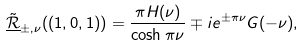Convert formula to latex. <formula><loc_0><loc_0><loc_500><loc_500>\tilde { \underline { \mathcal { R } } } _ { \pm , \nu } ( ( 1 , 0 , 1 ) ) = \frac { \pi H ( \nu ) } { \cosh \pi \nu } \mp i e ^ { \pm \pi \nu } G ( - \nu ) ,</formula> 